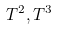Convert formula to latex. <formula><loc_0><loc_0><loc_500><loc_500>T ^ { 2 } , T ^ { 3 }</formula> 